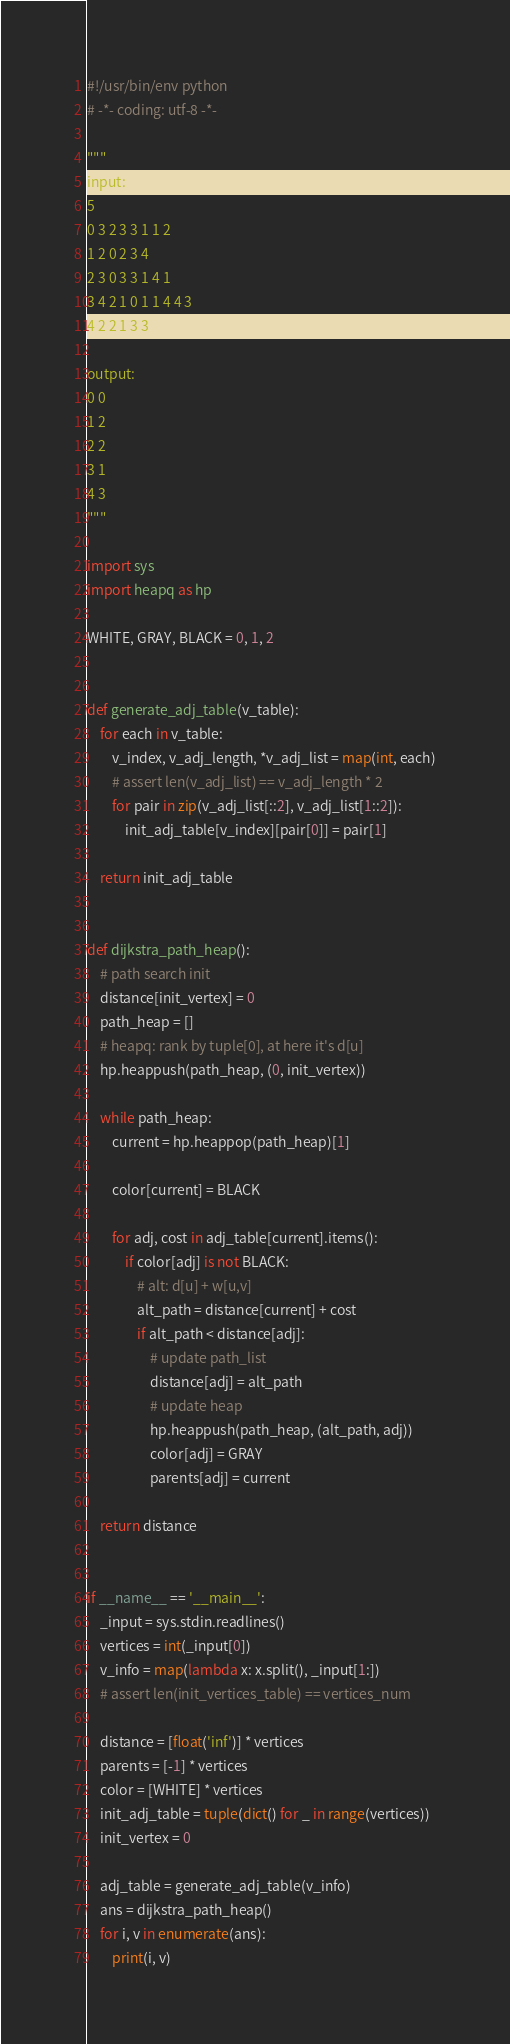<code> <loc_0><loc_0><loc_500><loc_500><_Python_>#!/usr/bin/env python
# -*- coding: utf-8 -*-

"""
input:
5
0 3 2 3 3 1 1 2
1 2 0 2 3 4
2 3 0 3 3 1 4 1
3 4 2 1 0 1 1 4 4 3
4 2 2 1 3 3

output:
0 0
1 2
2 2
3 1
4 3
"""

import sys
import heapq as hp

WHITE, GRAY, BLACK = 0, 1, 2


def generate_adj_table(v_table):
    for each in v_table:
        v_index, v_adj_length, *v_adj_list = map(int, each)
        # assert len(v_adj_list) == v_adj_length * 2
        for pair in zip(v_adj_list[::2], v_adj_list[1::2]):
            init_adj_table[v_index][pair[0]] = pair[1]

    return init_adj_table


def dijkstra_path_heap():
    # path search init
    distance[init_vertex] = 0
    path_heap = []
    # heapq: rank by tuple[0], at here it's d[u]
    hp.heappush(path_heap, (0, init_vertex))

    while path_heap:
        current = hp.heappop(path_heap)[1]

        color[current] = BLACK

        for adj, cost in adj_table[current].items():
            if color[adj] is not BLACK:
                # alt: d[u] + w[u,v]
                alt_path = distance[current] + cost
                if alt_path < distance[adj]:
                    # update path_list
                    distance[adj] = alt_path
                    # update heap
                    hp.heappush(path_heap, (alt_path, adj))
                    color[adj] = GRAY
                    parents[adj] = current

    return distance


if __name__ == '__main__':
    _input = sys.stdin.readlines()
    vertices = int(_input[0])
    v_info = map(lambda x: x.split(), _input[1:])
    # assert len(init_vertices_table) == vertices_num

    distance = [float('inf')] * vertices
    parents = [-1] * vertices
    color = [WHITE] * vertices
    init_adj_table = tuple(dict() for _ in range(vertices))
    init_vertex = 0

    adj_table = generate_adj_table(v_info)
    ans = dijkstra_path_heap()
    for i, v in enumerate(ans):
        print(i, v)</code> 